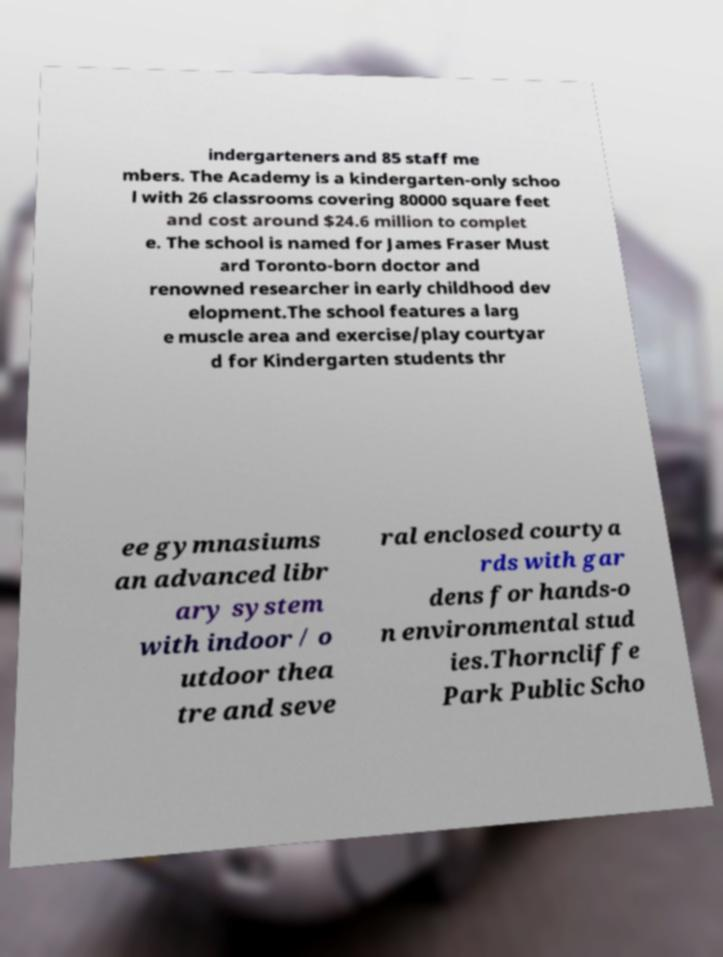Could you assist in decoding the text presented in this image and type it out clearly? indergarteners and 85 staff me mbers. The Academy is a kindergarten-only schoo l with 26 classrooms covering 80000 square feet and cost around $24.6 million to complet e. The school is named for James Fraser Must ard Toronto-born doctor and renowned researcher in early childhood dev elopment.The school features a larg e muscle area and exercise/play courtyar d for Kindergarten students thr ee gymnasiums an advanced libr ary system with indoor / o utdoor thea tre and seve ral enclosed courtya rds with gar dens for hands-o n environmental stud ies.Thorncliffe Park Public Scho 